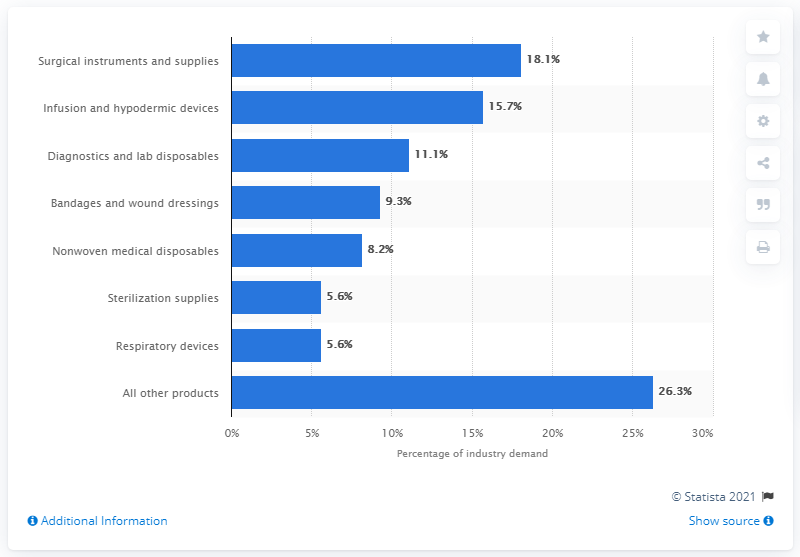Identify some key points in this picture. In 2015, diagnostics and lab disposables accounted for 11.1% of the global medical disposables market. 